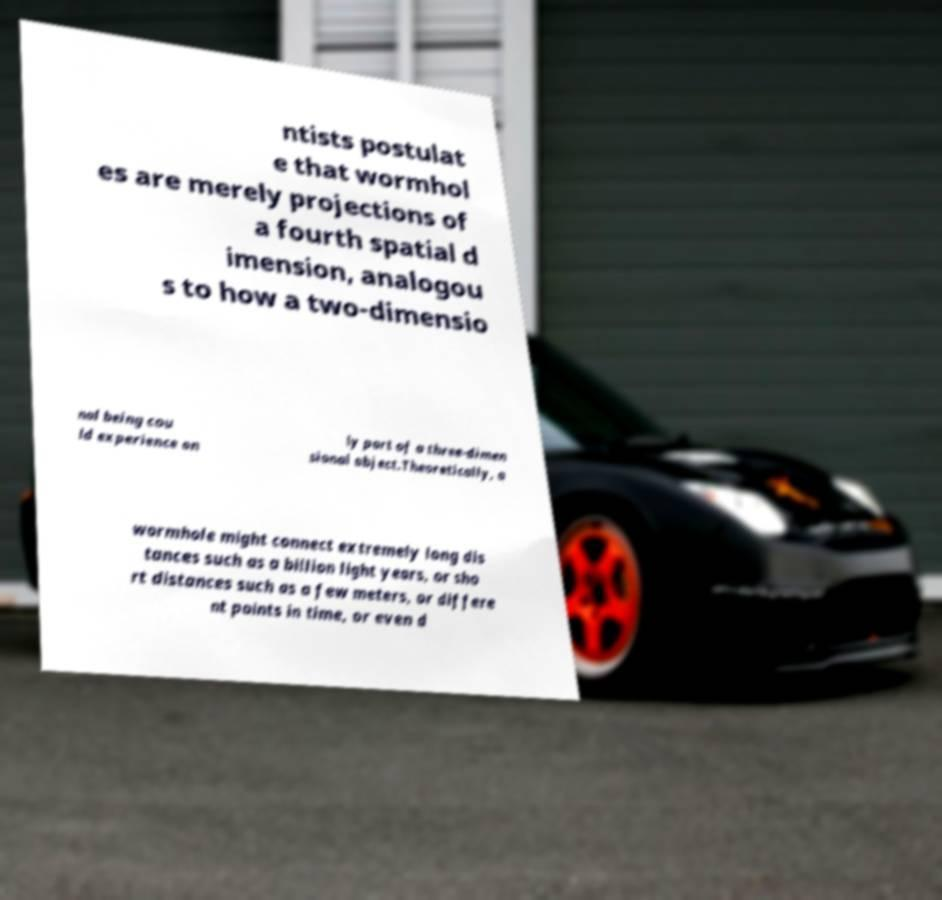I need the written content from this picture converted into text. Can you do that? ntists postulat e that wormhol es are merely projections of a fourth spatial d imension, analogou s to how a two-dimensio nal being cou ld experience on ly part of a three-dimen sional object.Theoretically, a wormhole might connect extremely long dis tances such as a billion light years, or sho rt distances such as a few meters, or differe nt points in time, or even d 